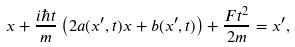Convert formula to latex. <formula><loc_0><loc_0><loc_500><loc_500>x + \frac { i \hbar { t } } { m } \left ( 2 a ( x ^ { \prime } , t ) x + b ( x ^ { \prime } , t ) \right ) + \frac { F t ^ { 2 } } { 2 m } = x ^ { \prime } ,</formula> 